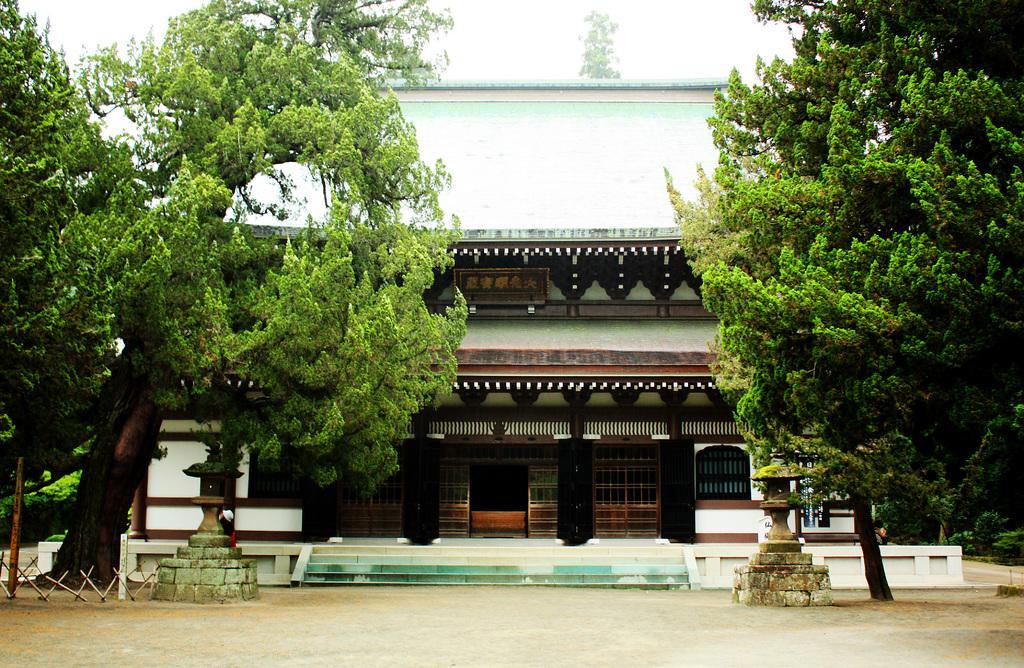In one or two sentences, can you explain what this image depicts? In this image, I can see a building and there are trees. In front of the building, there are pedestals. In the background, there is the sky. 